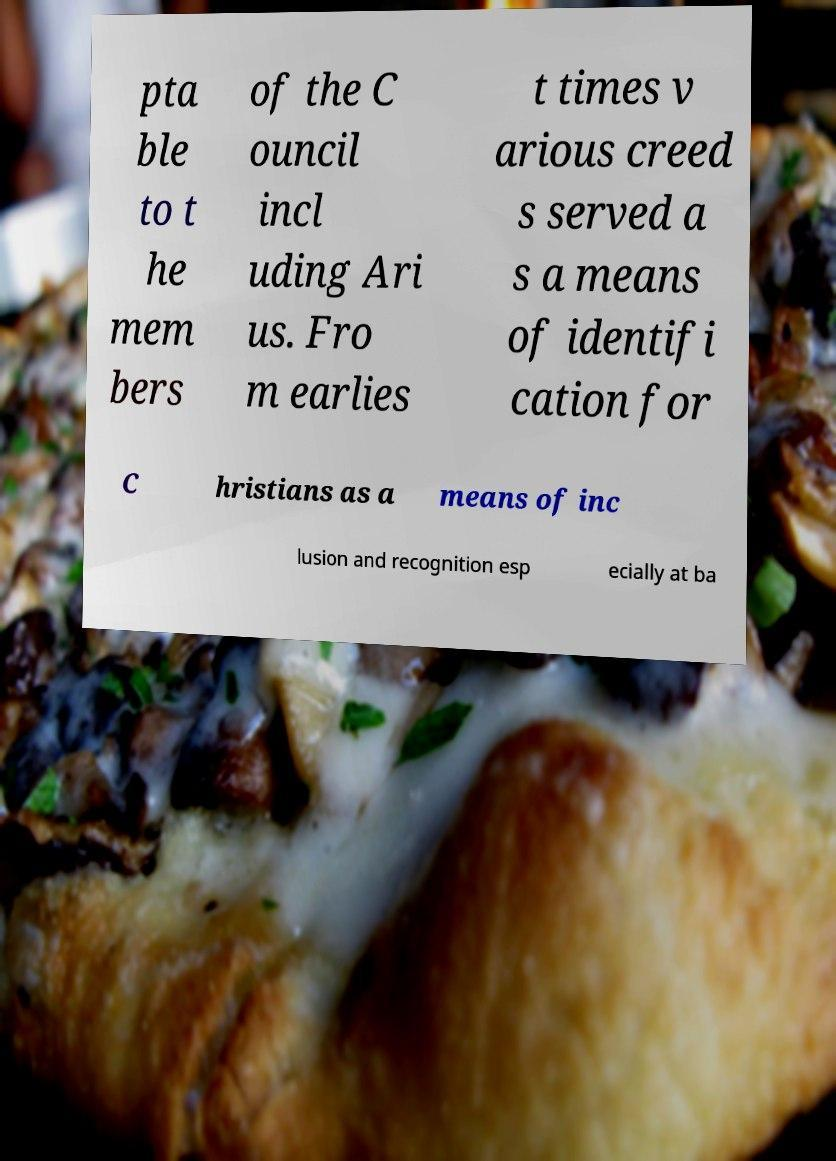Could you extract and type out the text from this image? pta ble to t he mem bers of the C ouncil incl uding Ari us. Fro m earlies t times v arious creed s served a s a means of identifi cation for C hristians as a means of inc lusion and recognition esp ecially at ba 